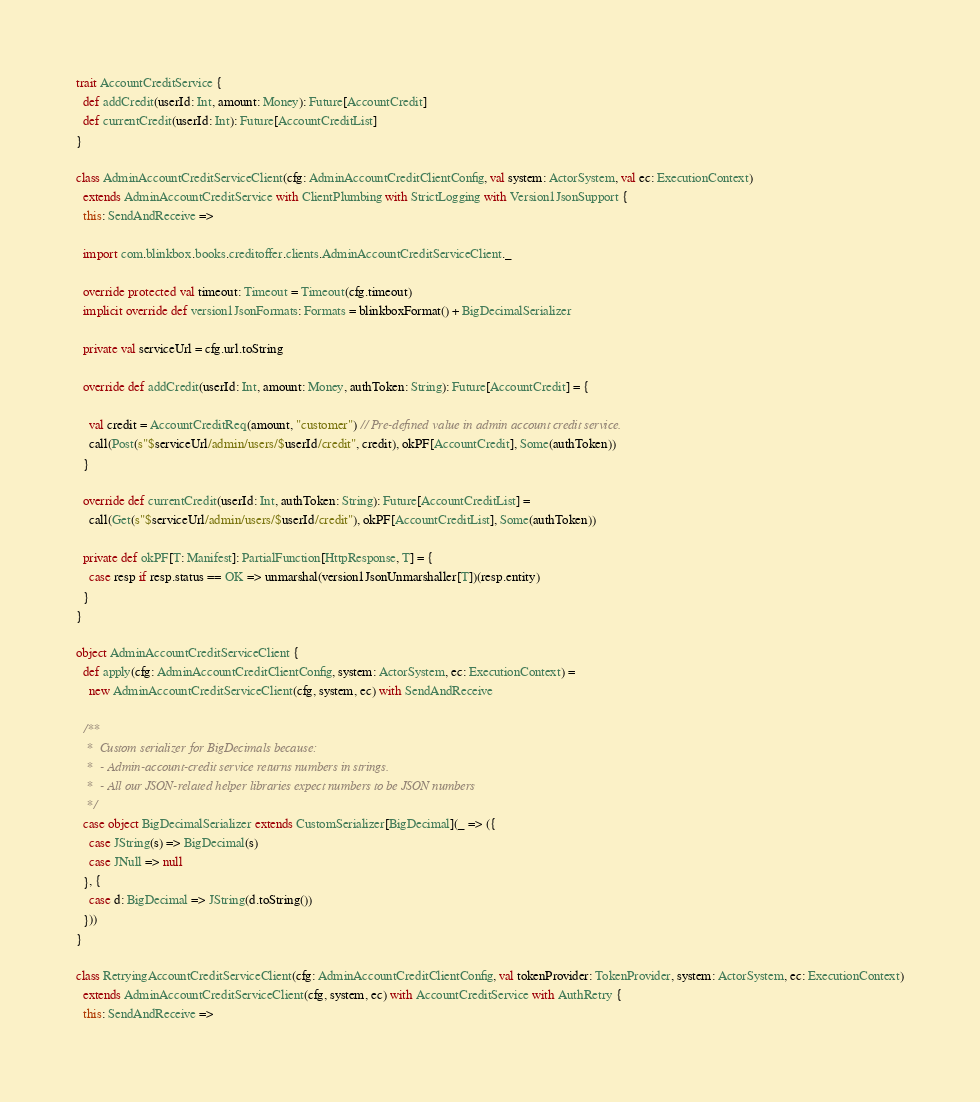<code> <loc_0><loc_0><loc_500><loc_500><_Scala_>
trait AccountCreditService {
  def addCredit(userId: Int, amount: Money): Future[AccountCredit]
  def currentCredit(userId: Int): Future[AccountCreditList]
}

class AdminAccountCreditServiceClient(cfg: AdminAccountCreditClientConfig, val system: ActorSystem, val ec: ExecutionContext)
  extends AdminAccountCreditService with ClientPlumbing with StrictLogging with Version1JsonSupport {
  this: SendAndReceive =>

  import com.blinkbox.books.creditoffer.clients.AdminAccountCreditServiceClient._

  override protected val timeout: Timeout = Timeout(cfg.timeout)
  implicit override def version1JsonFormats: Formats = blinkboxFormat() + BigDecimalSerializer

  private val serviceUrl = cfg.url.toString

  override def addCredit(userId: Int, amount: Money, authToken: String): Future[AccountCredit] = {

    val credit = AccountCreditReq(amount, "customer") // Pre-defined value in admin account credit service.
    call(Post(s"$serviceUrl/admin/users/$userId/credit", credit), okPF[AccountCredit], Some(authToken))
  }

  override def currentCredit(userId: Int, authToken: String): Future[AccountCreditList] =
    call(Get(s"$serviceUrl/admin/users/$userId/credit"), okPF[AccountCreditList], Some(authToken))

  private def okPF[T: Manifest]: PartialFunction[HttpResponse, T] = {
    case resp if resp.status == OK => unmarshal(version1JsonUnmarshaller[T])(resp.entity)
  }
}

object AdminAccountCreditServiceClient {
  def apply(cfg: AdminAccountCreditClientConfig, system: ActorSystem, ec: ExecutionContext) =
    new AdminAccountCreditServiceClient(cfg, system, ec) with SendAndReceive

  /**
   *  Custom serializer for BigDecimals because:
   *  - Admin-account-credit service returns numbers in strings.
   *  - All our JSON-related helper libraries expect numbers to be JSON numbers
   */
  case object BigDecimalSerializer extends CustomSerializer[BigDecimal](_ => ({
    case JString(s) => BigDecimal(s)
    case JNull => null
  }, {
    case d: BigDecimal => JString(d.toString())
  }))
}

class RetryingAccountCreditServiceClient(cfg: AdminAccountCreditClientConfig, val tokenProvider: TokenProvider, system: ActorSystem, ec: ExecutionContext)
  extends AdminAccountCreditServiceClient(cfg, system, ec) with AccountCreditService with AuthRetry {
  this: SendAndReceive =>
</code> 